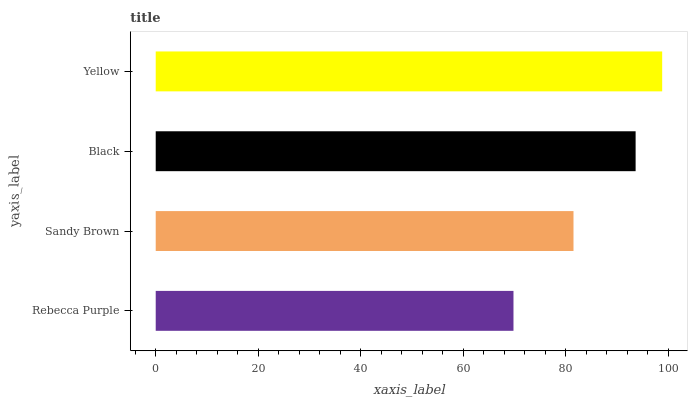Is Rebecca Purple the minimum?
Answer yes or no. Yes. Is Yellow the maximum?
Answer yes or no. Yes. Is Sandy Brown the minimum?
Answer yes or no. No. Is Sandy Brown the maximum?
Answer yes or no. No. Is Sandy Brown greater than Rebecca Purple?
Answer yes or no. Yes. Is Rebecca Purple less than Sandy Brown?
Answer yes or no. Yes. Is Rebecca Purple greater than Sandy Brown?
Answer yes or no. No. Is Sandy Brown less than Rebecca Purple?
Answer yes or no. No. Is Black the high median?
Answer yes or no. Yes. Is Sandy Brown the low median?
Answer yes or no. Yes. Is Yellow the high median?
Answer yes or no. No. Is Rebecca Purple the low median?
Answer yes or no. No. 